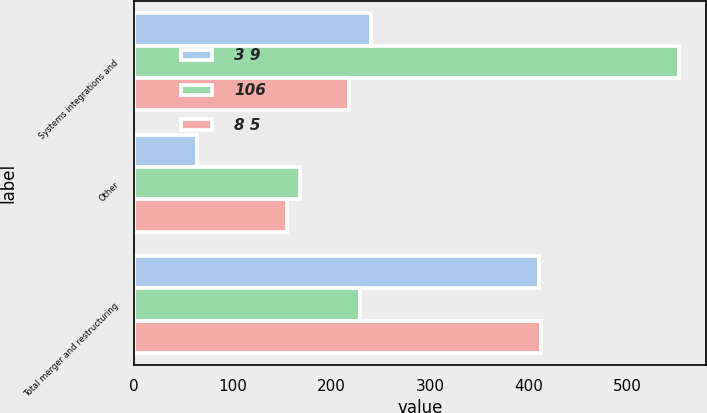Convert chart to OTSL. <chart><loc_0><loc_0><loc_500><loc_500><stacked_bar_chart><ecel><fcel>Systems integrations and<fcel>Other<fcel>Total merger and restructuring<nl><fcel>3 9<fcel>240<fcel>64<fcel>410<nl><fcel>106<fcel>552<fcel>168<fcel>229<nl><fcel>8 5<fcel>218<fcel>155<fcel>412<nl></chart> 